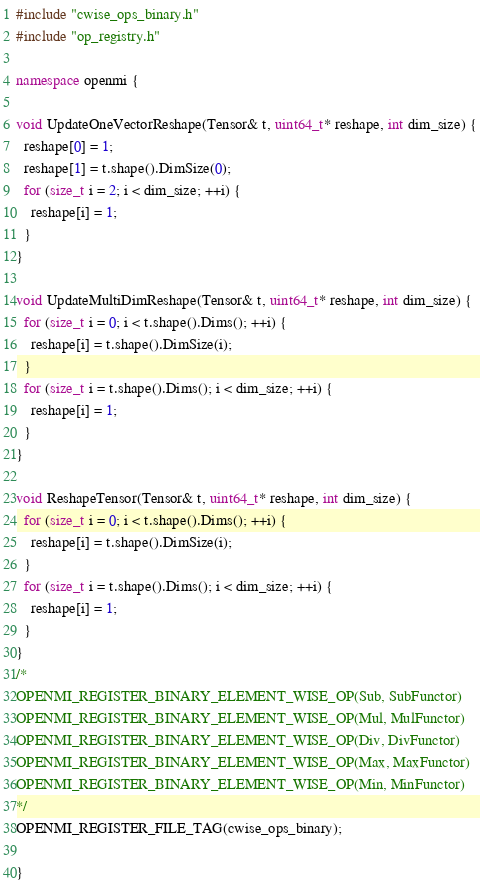Convert code to text. <code><loc_0><loc_0><loc_500><loc_500><_C++_>#include "cwise_ops_binary.h"
#include "op_registry.h"

namespace openmi {

void UpdateOneVectorReshape(Tensor& t, uint64_t* reshape, int dim_size) {
  reshape[0] = 1;
  reshape[1] = t.shape().DimSize(0);
  for (size_t i = 2; i < dim_size; ++i) {
    reshape[i] = 1;
  }
}

void UpdateMultiDimReshape(Tensor& t, uint64_t* reshape, int dim_size) {
  for (size_t i = 0; i < t.shape().Dims(); ++i) {
    reshape[i] = t.shape().DimSize(i);
  }
  for (size_t i = t.shape().Dims(); i < dim_size; ++i) {
    reshape[i] = 1;
  }
}

void ReshapeTensor(Tensor& t, uint64_t* reshape, int dim_size) {
  for (size_t i = 0; i < t.shape().Dims(); ++i) {
    reshape[i] = t.shape().DimSize(i);
  }
  for (size_t i = t.shape().Dims(); i < dim_size; ++i) {
    reshape[i] = 1;
  }
}
/*
OPENMI_REGISTER_BINARY_ELEMENT_WISE_OP(Sub, SubFunctor)
OPENMI_REGISTER_BINARY_ELEMENT_WISE_OP(Mul, MulFunctor)
OPENMI_REGISTER_BINARY_ELEMENT_WISE_OP(Div, DivFunctor)
OPENMI_REGISTER_BINARY_ELEMENT_WISE_OP(Max, MaxFunctor)
OPENMI_REGISTER_BINARY_ELEMENT_WISE_OP(Min, MinFunctor)
*/
OPENMI_REGISTER_FILE_TAG(cwise_ops_binary);

}
</code> 